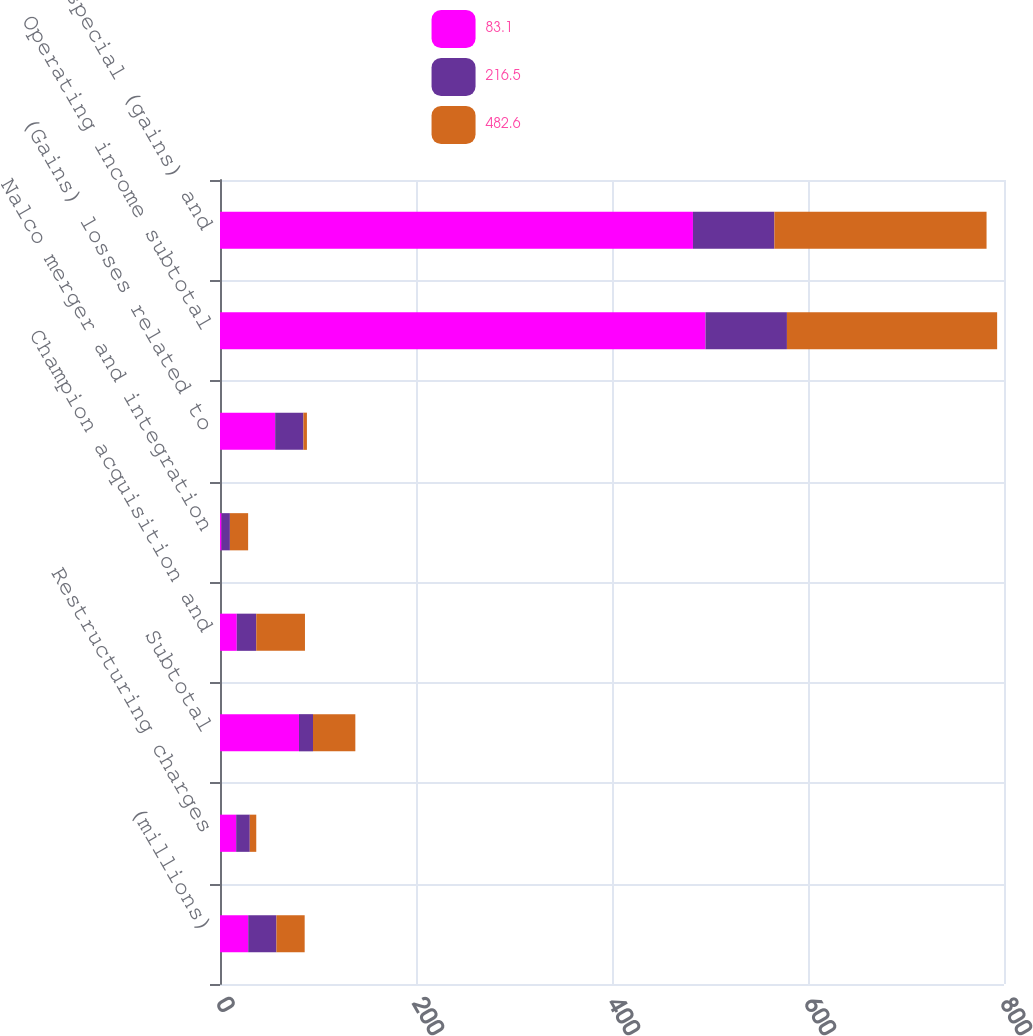Convert chart to OTSL. <chart><loc_0><loc_0><loc_500><loc_500><stacked_bar_chart><ecel><fcel>(millions)<fcel>Restructuring charges<fcel>Subtotal<fcel>Champion acquisition and<fcel>Nalco merger and integration<fcel>(Gains) losses related to<fcel>Operating income subtotal<fcel>Total special (gains) and<nl><fcel>83.1<fcel>28.8<fcel>16.5<fcel>80.6<fcel>17.1<fcel>1.6<fcel>56.3<fcel>495.4<fcel>482.6<nl><fcel>216.5<fcel>28.8<fcel>13.9<fcel>14.3<fcel>19.9<fcel>8.5<fcel>28.8<fcel>83.1<fcel>83.1<nl><fcel>482.6<fcel>28.8<fcel>6.6<fcel>43.2<fcel>49.7<fcel>18.6<fcel>3.6<fcel>214.5<fcel>216.5<nl></chart> 